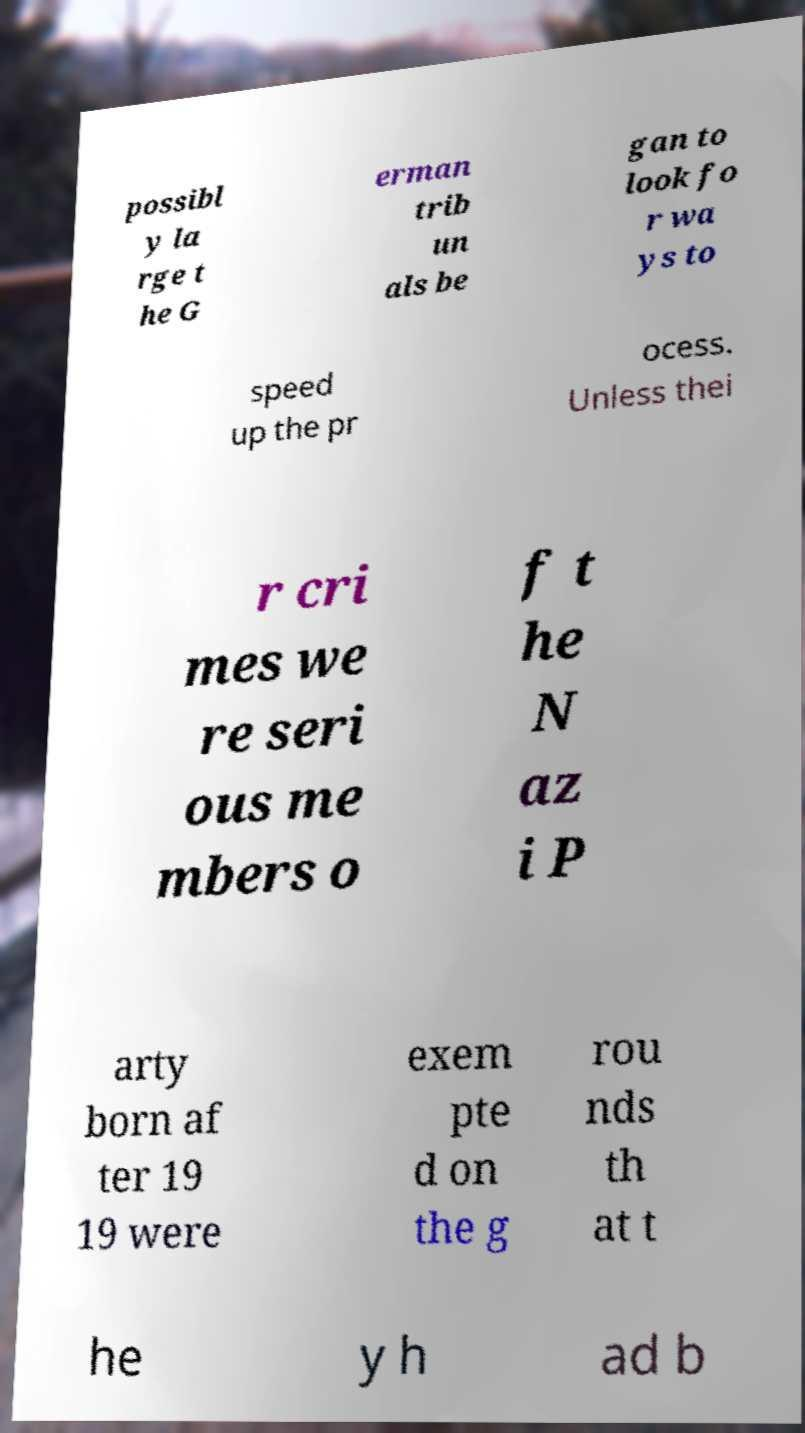For documentation purposes, I need the text within this image transcribed. Could you provide that? possibl y la rge t he G erman trib un als be gan to look fo r wa ys to speed up the pr ocess. Unless thei r cri mes we re seri ous me mbers o f t he N az i P arty born af ter 19 19 were exem pte d on the g rou nds th at t he y h ad b 